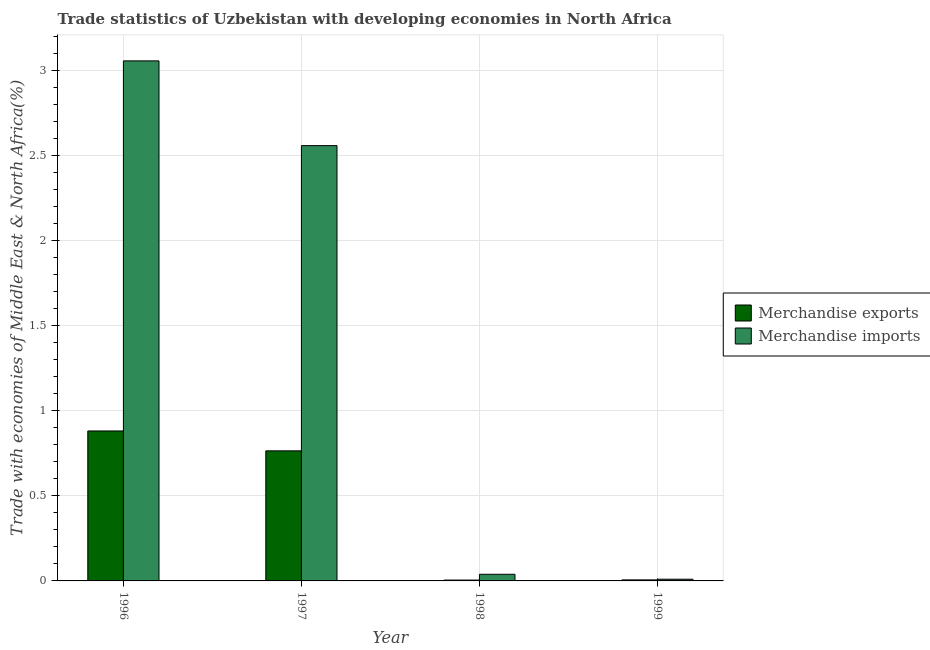How many different coloured bars are there?
Provide a short and direct response. 2. Are the number of bars per tick equal to the number of legend labels?
Provide a succinct answer. Yes. Are the number of bars on each tick of the X-axis equal?
Ensure brevity in your answer.  Yes. What is the label of the 3rd group of bars from the left?
Provide a short and direct response. 1998. What is the merchandise exports in 1999?
Your answer should be very brief. 0.01. Across all years, what is the maximum merchandise imports?
Give a very brief answer. 3.06. Across all years, what is the minimum merchandise imports?
Your response must be concise. 0.01. In which year was the merchandise exports maximum?
Give a very brief answer. 1996. In which year was the merchandise imports minimum?
Your response must be concise. 1999. What is the total merchandise imports in the graph?
Your response must be concise. 5.66. What is the difference between the merchandise imports in 1998 and that in 1999?
Your answer should be compact. 0.03. What is the difference between the merchandise exports in 1997 and the merchandise imports in 1996?
Your response must be concise. -0.12. What is the average merchandise imports per year?
Provide a succinct answer. 1.42. In the year 1999, what is the difference between the merchandise exports and merchandise imports?
Offer a terse response. 0. What is the ratio of the merchandise exports in 1996 to that in 1999?
Offer a terse response. 146.76. Is the merchandise imports in 1996 less than that in 1997?
Offer a terse response. No. What is the difference between the highest and the second highest merchandise imports?
Provide a succinct answer. 0.5. What is the difference between the highest and the lowest merchandise imports?
Your response must be concise. 3.05. Is the sum of the merchandise exports in 1996 and 1998 greater than the maximum merchandise imports across all years?
Make the answer very short. Yes. What does the 2nd bar from the left in 1999 represents?
Offer a terse response. Merchandise imports. Are all the bars in the graph horizontal?
Your response must be concise. No. How many years are there in the graph?
Provide a succinct answer. 4. What is the difference between two consecutive major ticks on the Y-axis?
Keep it short and to the point. 0.5. Does the graph contain any zero values?
Your answer should be compact. No. How many legend labels are there?
Provide a succinct answer. 2. What is the title of the graph?
Provide a succinct answer. Trade statistics of Uzbekistan with developing economies in North Africa. What is the label or title of the Y-axis?
Provide a succinct answer. Trade with economies of Middle East & North Africa(%). What is the Trade with economies of Middle East & North Africa(%) of Merchandise exports in 1996?
Your response must be concise. 0.88. What is the Trade with economies of Middle East & North Africa(%) of Merchandise imports in 1996?
Offer a very short reply. 3.06. What is the Trade with economies of Middle East & North Africa(%) in Merchandise exports in 1997?
Keep it short and to the point. 0.76. What is the Trade with economies of Middle East & North Africa(%) in Merchandise imports in 1997?
Make the answer very short. 2.56. What is the Trade with economies of Middle East & North Africa(%) in Merchandise exports in 1998?
Your answer should be compact. 0.01. What is the Trade with economies of Middle East & North Africa(%) of Merchandise imports in 1998?
Give a very brief answer. 0.04. What is the Trade with economies of Middle East & North Africa(%) of Merchandise exports in 1999?
Provide a succinct answer. 0.01. What is the Trade with economies of Middle East & North Africa(%) of Merchandise imports in 1999?
Provide a short and direct response. 0.01. Across all years, what is the maximum Trade with economies of Middle East & North Africa(%) in Merchandise exports?
Ensure brevity in your answer.  0.88. Across all years, what is the maximum Trade with economies of Middle East & North Africa(%) in Merchandise imports?
Your answer should be compact. 3.06. Across all years, what is the minimum Trade with economies of Middle East & North Africa(%) of Merchandise exports?
Provide a short and direct response. 0.01. Across all years, what is the minimum Trade with economies of Middle East & North Africa(%) of Merchandise imports?
Provide a succinct answer. 0.01. What is the total Trade with economies of Middle East & North Africa(%) of Merchandise exports in the graph?
Your answer should be very brief. 1.66. What is the total Trade with economies of Middle East & North Africa(%) in Merchandise imports in the graph?
Keep it short and to the point. 5.66. What is the difference between the Trade with economies of Middle East & North Africa(%) of Merchandise exports in 1996 and that in 1997?
Give a very brief answer. 0.12. What is the difference between the Trade with economies of Middle East & North Africa(%) in Merchandise imports in 1996 and that in 1997?
Offer a very short reply. 0.5. What is the difference between the Trade with economies of Middle East & North Africa(%) in Merchandise exports in 1996 and that in 1998?
Provide a succinct answer. 0.88. What is the difference between the Trade with economies of Middle East & North Africa(%) in Merchandise imports in 1996 and that in 1998?
Your response must be concise. 3.02. What is the difference between the Trade with economies of Middle East & North Africa(%) of Merchandise exports in 1996 and that in 1999?
Make the answer very short. 0.88. What is the difference between the Trade with economies of Middle East & North Africa(%) of Merchandise imports in 1996 and that in 1999?
Offer a very short reply. 3.05. What is the difference between the Trade with economies of Middle East & North Africa(%) of Merchandise exports in 1997 and that in 1998?
Your answer should be very brief. 0.76. What is the difference between the Trade with economies of Middle East & North Africa(%) of Merchandise imports in 1997 and that in 1998?
Offer a very short reply. 2.52. What is the difference between the Trade with economies of Middle East & North Africa(%) in Merchandise exports in 1997 and that in 1999?
Your answer should be very brief. 0.76. What is the difference between the Trade with economies of Middle East & North Africa(%) of Merchandise imports in 1997 and that in 1999?
Make the answer very short. 2.55. What is the difference between the Trade with economies of Middle East & North Africa(%) of Merchandise exports in 1998 and that in 1999?
Provide a short and direct response. -0. What is the difference between the Trade with economies of Middle East & North Africa(%) of Merchandise imports in 1998 and that in 1999?
Make the answer very short. 0.03. What is the difference between the Trade with economies of Middle East & North Africa(%) of Merchandise exports in 1996 and the Trade with economies of Middle East & North Africa(%) of Merchandise imports in 1997?
Your answer should be very brief. -1.68. What is the difference between the Trade with economies of Middle East & North Africa(%) of Merchandise exports in 1996 and the Trade with economies of Middle East & North Africa(%) of Merchandise imports in 1998?
Provide a succinct answer. 0.84. What is the difference between the Trade with economies of Middle East & North Africa(%) of Merchandise exports in 1996 and the Trade with economies of Middle East & North Africa(%) of Merchandise imports in 1999?
Your response must be concise. 0.87. What is the difference between the Trade with economies of Middle East & North Africa(%) in Merchandise exports in 1997 and the Trade with economies of Middle East & North Africa(%) in Merchandise imports in 1998?
Make the answer very short. 0.73. What is the difference between the Trade with economies of Middle East & North Africa(%) of Merchandise exports in 1997 and the Trade with economies of Middle East & North Africa(%) of Merchandise imports in 1999?
Provide a succinct answer. 0.75. What is the difference between the Trade with economies of Middle East & North Africa(%) of Merchandise exports in 1998 and the Trade with economies of Middle East & North Africa(%) of Merchandise imports in 1999?
Your answer should be very brief. -0.01. What is the average Trade with economies of Middle East & North Africa(%) in Merchandise exports per year?
Your answer should be very brief. 0.41. What is the average Trade with economies of Middle East & North Africa(%) in Merchandise imports per year?
Offer a terse response. 1.42. In the year 1996, what is the difference between the Trade with economies of Middle East & North Africa(%) in Merchandise exports and Trade with economies of Middle East & North Africa(%) in Merchandise imports?
Make the answer very short. -2.17. In the year 1997, what is the difference between the Trade with economies of Middle East & North Africa(%) of Merchandise exports and Trade with economies of Middle East & North Africa(%) of Merchandise imports?
Ensure brevity in your answer.  -1.79. In the year 1998, what is the difference between the Trade with economies of Middle East & North Africa(%) of Merchandise exports and Trade with economies of Middle East & North Africa(%) of Merchandise imports?
Your response must be concise. -0.03. In the year 1999, what is the difference between the Trade with economies of Middle East & North Africa(%) of Merchandise exports and Trade with economies of Middle East & North Africa(%) of Merchandise imports?
Ensure brevity in your answer.  -0. What is the ratio of the Trade with economies of Middle East & North Africa(%) in Merchandise exports in 1996 to that in 1997?
Provide a short and direct response. 1.15. What is the ratio of the Trade with economies of Middle East & North Africa(%) in Merchandise imports in 1996 to that in 1997?
Offer a terse response. 1.19. What is the ratio of the Trade with economies of Middle East & North Africa(%) of Merchandise exports in 1996 to that in 1998?
Provide a short and direct response. 175.5. What is the ratio of the Trade with economies of Middle East & North Africa(%) of Merchandise imports in 1996 to that in 1998?
Provide a succinct answer. 78.14. What is the ratio of the Trade with economies of Middle East & North Africa(%) of Merchandise exports in 1996 to that in 1999?
Give a very brief answer. 146.76. What is the ratio of the Trade with economies of Middle East & North Africa(%) of Merchandise imports in 1996 to that in 1999?
Your answer should be compact. 304.64. What is the ratio of the Trade with economies of Middle East & North Africa(%) of Merchandise exports in 1997 to that in 1998?
Your response must be concise. 152.21. What is the ratio of the Trade with economies of Middle East & North Africa(%) of Merchandise imports in 1997 to that in 1998?
Keep it short and to the point. 65.41. What is the ratio of the Trade with economies of Middle East & North Africa(%) in Merchandise exports in 1997 to that in 1999?
Provide a succinct answer. 127.28. What is the ratio of the Trade with economies of Middle East & North Africa(%) of Merchandise imports in 1997 to that in 1999?
Ensure brevity in your answer.  255.01. What is the ratio of the Trade with economies of Middle East & North Africa(%) of Merchandise exports in 1998 to that in 1999?
Offer a very short reply. 0.84. What is the ratio of the Trade with economies of Middle East & North Africa(%) in Merchandise imports in 1998 to that in 1999?
Give a very brief answer. 3.9. What is the difference between the highest and the second highest Trade with economies of Middle East & North Africa(%) of Merchandise exports?
Give a very brief answer. 0.12. What is the difference between the highest and the second highest Trade with economies of Middle East & North Africa(%) of Merchandise imports?
Provide a succinct answer. 0.5. What is the difference between the highest and the lowest Trade with economies of Middle East & North Africa(%) in Merchandise exports?
Provide a succinct answer. 0.88. What is the difference between the highest and the lowest Trade with economies of Middle East & North Africa(%) of Merchandise imports?
Give a very brief answer. 3.05. 